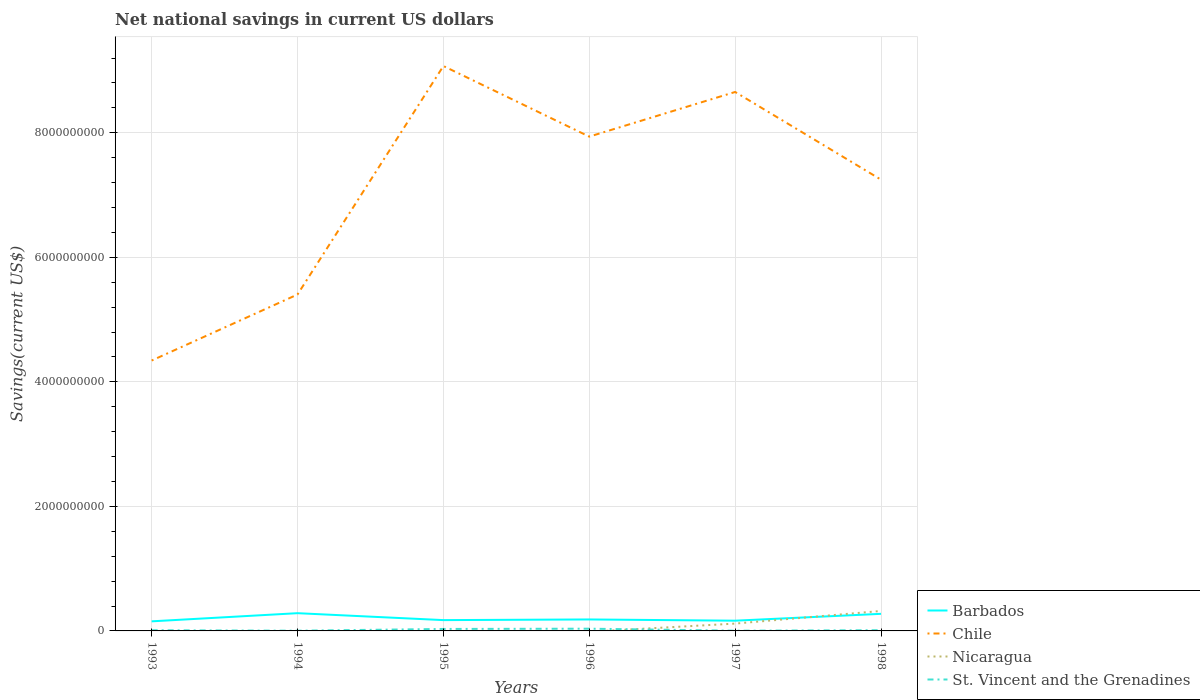How many different coloured lines are there?
Provide a succinct answer. 4. Does the line corresponding to Nicaragua intersect with the line corresponding to Barbados?
Offer a terse response. Yes. Across all years, what is the maximum net national savings in St. Vincent and the Grenadines?
Your answer should be very brief. 3.37e+06. What is the total net national savings in Barbados in the graph?
Offer a terse response. -1.10e+08. What is the difference between the highest and the second highest net national savings in Chile?
Offer a very short reply. 4.73e+09. Is the net national savings in Chile strictly greater than the net national savings in St. Vincent and the Grenadines over the years?
Offer a terse response. No. How many lines are there?
Your answer should be compact. 4. How many years are there in the graph?
Offer a terse response. 6. What is the difference between two consecutive major ticks on the Y-axis?
Keep it short and to the point. 2.00e+09. Does the graph contain grids?
Keep it short and to the point. Yes. How many legend labels are there?
Provide a succinct answer. 4. What is the title of the graph?
Offer a terse response. Net national savings in current US dollars. What is the label or title of the Y-axis?
Ensure brevity in your answer.  Savings(current US$). What is the Savings(current US$) in Barbados in 1993?
Ensure brevity in your answer.  1.54e+08. What is the Savings(current US$) in Chile in 1993?
Ensure brevity in your answer.  4.34e+09. What is the Savings(current US$) in St. Vincent and the Grenadines in 1993?
Your answer should be very brief. 1.11e+07. What is the Savings(current US$) of Barbados in 1994?
Give a very brief answer. 2.85e+08. What is the Savings(current US$) of Chile in 1994?
Your answer should be compact. 5.40e+09. What is the Savings(current US$) in St. Vincent and the Grenadines in 1994?
Provide a short and direct response. 3.37e+06. What is the Savings(current US$) in Barbados in 1995?
Your answer should be compact. 1.74e+08. What is the Savings(current US$) in Chile in 1995?
Keep it short and to the point. 9.07e+09. What is the Savings(current US$) in St. Vincent and the Grenadines in 1995?
Give a very brief answer. 3.17e+07. What is the Savings(current US$) of Barbados in 1996?
Make the answer very short. 1.84e+08. What is the Savings(current US$) of Chile in 1996?
Your answer should be compact. 7.94e+09. What is the Savings(current US$) of Nicaragua in 1996?
Make the answer very short. 0. What is the Savings(current US$) of St. Vincent and the Grenadines in 1996?
Provide a succinct answer. 3.58e+07. What is the Savings(current US$) of Barbados in 1997?
Offer a very short reply. 1.64e+08. What is the Savings(current US$) of Chile in 1997?
Your answer should be very brief. 8.65e+09. What is the Savings(current US$) of Nicaragua in 1997?
Your response must be concise. 1.18e+08. What is the Savings(current US$) of St. Vincent and the Grenadines in 1997?
Keep it short and to the point. 3.52e+06. What is the Savings(current US$) in Barbados in 1998?
Make the answer very short. 2.74e+08. What is the Savings(current US$) in Chile in 1998?
Give a very brief answer. 7.25e+09. What is the Savings(current US$) in Nicaragua in 1998?
Your response must be concise. 3.21e+08. What is the Savings(current US$) in St. Vincent and the Grenadines in 1998?
Your answer should be compact. 1.14e+07. Across all years, what is the maximum Savings(current US$) in Barbados?
Make the answer very short. 2.85e+08. Across all years, what is the maximum Savings(current US$) in Chile?
Make the answer very short. 9.07e+09. Across all years, what is the maximum Savings(current US$) in Nicaragua?
Keep it short and to the point. 3.21e+08. Across all years, what is the maximum Savings(current US$) in St. Vincent and the Grenadines?
Provide a short and direct response. 3.58e+07. Across all years, what is the minimum Savings(current US$) of Barbados?
Offer a very short reply. 1.54e+08. Across all years, what is the minimum Savings(current US$) in Chile?
Give a very brief answer. 4.34e+09. Across all years, what is the minimum Savings(current US$) in St. Vincent and the Grenadines?
Your answer should be very brief. 3.37e+06. What is the total Savings(current US$) of Barbados in the graph?
Your response must be concise. 1.24e+09. What is the total Savings(current US$) of Chile in the graph?
Give a very brief answer. 4.27e+1. What is the total Savings(current US$) in Nicaragua in the graph?
Provide a short and direct response. 4.38e+08. What is the total Savings(current US$) of St. Vincent and the Grenadines in the graph?
Your answer should be very brief. 9.69e+07. What is the difference between the Savings(current US$) of Barbados in 1993 and that in 1994?
Your response must be concise. -1.31e+08. What is the difference between the Savings(current US$) in Chile in 1993 and that in 1994?
Provide a short and direct response. -1.06e+09. What is the difference between the Savings(current US$) in St. Vincent and the Grenadines in 1993 and that in 1994?
Provide a succinct answer. 7.76e+06. What is the difference between the Savings(current US$) of Barbados in 1993 and that in 1995?
Provide a succinct answer. -1.97e+07. What is the difference between the Savings(current US$) in Chile in 1993 and that in 1995?
Your answer should be compact. -4.73e+09. What is the difference between the Savings(current US$) in St. Vincent and the Grenadines in 1993 and that in 1995?
Keep it short and to the point. -2.05e+07. What is the difference between the Savings(current US$) of Barbados in 1993 and that in 1996?
Your answer should be compact. -3.03e+07. What is the difference between the Savings(current US$) of Chile in 1993 and that in 1996?
Make the answer very short. -3.60e+09. What is the difference between the Savings(current US$) in St. Vincent and the Grenadines in 1993 and that in 1996?
Your answer should be very brief. -2.46e+07. What is the difference between the Savings(current US$) in Barbados in 1993 and that in 1997?
Provide a succinct answer. -1.05e+07. What is the difference between the Savings(current US$) of Chile in 1993 and that in 1997?
Make the answer very short. -4.31e+09. What is the difference between the Savings(current US$) in St. Vincent and the Grenadines in 1993 and that in 1997?
Make the answer very short. 7.60e+06. What is the difference between the Savings(current US$) of Barbados in 1993 and that in 1998?
Your answer should be compact. -1.21e+08. What is the difference between the Savings(current US$) in Chile in 1993 and that in 1998?
Provide a short and direct response. -2.90e+09. What is the difference between the Savings(current US$) of St. Vincent and the Grenadines in 1993 and that in 1998?
Your answer should be compact. -2.82e+05. What is the difference between the Savings(current US$) of Barbados in 1994 and that in 1995?
Keep it short and to the point. 1.11e+08. What is the difference between the Savings(current US$) in Chile in 1994 and that in 1995?
Your response must be concise. -3.67e+09. What is the difference between the Savings(current US$) in St. Vincent and the Grenadines in 1994 and that in 1995?
Offer a terse response. -2.83e+07. What is the difference between the Savings(current US$) in Barbados in 1994 and that in 1996?
Provide a short and direct response. 1.01e+08. What is the difference between the Savings(current US$) of Chile in 1994 and that in 1996?
Your answer should be compact. -2.54e+09. What is the difference between the Savings(current US$) in St. Vincent and the Grenadines in 1994 and that in 1996?
Your answer should be compact. -3.24e+07. What is the difference between the Savings(current US$) in Barbados in 1994 and that in 1997?
Offer a terse response. 1.21e+08. What is the difference between the Savings(current US$) of Chile in 1994 and that in 1997?
Make the answer very short. -3.25e+09. What is the difference between the Savings(current US$) in St. Vincent and the Grenadines in 1994 and that in 1997?
Keep it short and to the point. -1.56e+05. What is the difference between the Savings(current US$) in Barbados in 1994 and that in 1998?
Your answer should be very brief. 1.04e+07. What is the difference between the Savings(current US$) in Chile in 1994 and that in 1998?
Provide a succinct answer. -1.84e+09. What is the difference between the Savings(current US$) of St. Vincent and the Grenadines in 1994 and that in 1998?
Your answer should be compact. -8.04e+06. What is the difference between the Savings(current US$) of Barbados in 1995 and that in 1996?
Your response must be concise. -1.07e+07. What is the difference between the Savings(current US$) of Chile in 1995 and that in 1996?
Keep it short and to the point. 1.13e+09. What is the difference between the Savings(current US$) in St. Vincent and the Grenadines in 1995 and that in 1996?
Offer a terse response. -4.11e+06. What is the difference between the Savings(current US$) in Barbados in 1995 and that in 1997?
Your answer should be very brief. 9.19e+06. What is the difference between the Savings(current US$) of Chile in 1995 and that in 1997?
Ensure brevity in your answer.  4.17e+08. What is the difference between the Savings(current US$) of St. Vincent and the Grenadines in 1995 and that in 1997?
Provide a short and direct response. 2.81e+07. What is the difference between the Savings(current US$) in Barbados in 1995 and that in 1998?
Your answer should be very brief. -1.01e+08. What is the difference between the Savings(current US$) in Chile in 1995 and that in 1998?
Ensure brevity in your answer.  1.82e+09. What is the difference between the Savings(current US$) of St. Vincent and the Grenadines in 1995 and that in 1998?
Provide a short and direct response. 2.03e+07. What is the difference between the Savings(current US$) in Barbados in 1996 and that in 1997?
Provide a short and direct response. 1.99e+07. What is the difference between the Savings(current US$) in Chile in 1996 and that in 1997?
Give a very brief answer. -7.17e+08. What is the difference between the Savings(current US$) in St. Vincent and the Grenadines in 1996 and that in 1997?
Give a very brief answer. 3.22e+07. What is the difference between the Savings(current US$) in Barbados in 1996 and that in 1998?
Provide a succinct answer. -9.03e+07. What is the difference between the Savings(current US$) of Chile in 1996 and that in 1998?
Your answer should be compact. 6.91e+08. What is the difference between the Savings(current US$) in St. Vincent and the Grenadines in 1996 and that in 1998?
Ensure brevity in your answer.  2.44e+07. What is the difference between the Savings(current US$) in Barbados in 1997 and that in 1998?
Keep it short and to the point. -1.10e+08. What is the difference between the Savings(current US$) in Chile in 1997 and that in 1998?
Keep it short and to the point. 1.41e+09. What is the difference between the Savings(current US$) in Nicaragua in 1997 and that in 1998?
Your answer should be very brief. -2.03e+08. What is the difference between the Savings(current US$) of St. Vincent and the Grenadines in 1997 and that in 1998?
Give a very brief answer. -7.88e+06. What is the difference between the Savings(current US$) in Barbados in 1993 and the Savings(current US$) in Chile in 1994?
Keep it short and to the point. -5.25e+09. What is the difference between the Savings(current US$) of Barbados in 1993 and the Savings(current US$) of St. Vincent and the Grenadines in 1994?
Offer a terse response. 1.51e+08. What is the difference between the Savings(current US$) of Chile in 1993 and the Savings(current US$) of St. Vincent and the Grenadines in 1994?
Provide a short and direct response. 4.34e+09. What is the difference between the Savings(current US$) of Barbados in 1993 and the Savings(current US$) of Chile in 1995?
Provide a short and direct response. -8.92e+09. What is the difference between the Savings(current US$) of Barbados in 1993 and the Savings(current US$) of St. Vincent and the Grenadines in 1995?
Provide a short and direct response. 1.22e+08. What is the difference between the Savings(current US$) of Chile in 1993 and the Savings(current US$) of St. Vincent and the Grenadines in 1995?
Give a very brief answer. 4.31e+09. What is the difference between the Savings(current US$) in Barbados in 1993 and the Savings(current US$) in Chile in 1996?
Offer a terse response. -7.78e+09. What is the difference between the Savings(current US$) of Barbados in 1993 and the Savings(current US$) of St. Vincent and the Grenadines in 1996?
Your answer should be compact. 1.18e+08. What is the difference between the Savings(current US$) of Chile in 1993 and the Savings(current US$) of St. Vincent and the Grenadines in 1996?
Provide a short and direct response. 4.31e+09. What is the difference between the Savings(current US$) of Barbados in 1993 and the Savings(current US$) of Chile in 1997?
Give a very brief answer. -8.50e+09. What is the difference between the Savings(current US$) in Barbados in 1993 and the Savings(current US$) in Nicaragua in 1997?
Your answer should be very brief. 3.61e+07. What is the difference between the Savings(current US$) in Barbados in 1993 and the Savings(current US$) in St. Vincent and the Grenadines in 1997?
Give a very brief answer. 1.50e+08. What is the difference between the Savings(current US$) in Chile in 1993 and the Savings(current US$) in Nicaragua in 1997?
Your answer should be compact. 4.22e+09. What is the difference between the Savings(current US$) in Chile in 1993 and the Savings(current US$) in St. Vincent and the Grenadines in 1997?
Offer a very short reply. 4.34e+09. What is the difference between the Savings(current US$) in Barbados in 1993 and the Savings(current US$) in Chile in 1998?
Offer a terse response. -7.09e+09. What is the difference between the Savings(current US$) of Barbados in 1993 and the Savings(current US$) of Nicaragua in 1998?
Ensure brevity in your answer.  -1.67e+08. What is the difference between the Savings(current US$) of Barbados in 1993 and the Savings(current US$) of St. Vincent and the Grenadines in 1998?
Offer a very short reply. 1.42e+08. What is the difference between the Savings(current US$) in Chile in 1993 and the Savings(current US$) in Nicaragua in 1998?
Your response must be concise. 4.02e+09. What is the difference between the Savings(current US$) of Chile in 1993 and the Savings(current US$) of St. Vincent and the Grenadines in 1998?
Ensure brevity in your answer.  4.33e+09. What is the difference between the Savings(current US$) of Barbados in 1994 and the Savings(current US$) of Chile in 1995?
Provide a short and direct response. -8.79e+09. What is the difference between the Savings(current US$) in Barbados in 1994 and the Savings(current US$) in St. Vincent and the Grenadines in 1995?
Provide a succinct answer. 2.53e+08. What is the difference between the Savings(current US$) in Chile in 1994 and the Savings(current US$) in St. Vincent and the Grenadines in 1995?
Your answer should be very brief. 5.37e+09. What is the difference between the Savings(current US$) in Barbados in 1994 and the Savings(current US$) in Chile in 1996?
Make the answer very short. -7.65e+09. What is the difference between the Savings(current US$) in Barbados in 1994 and the Savings(current US$) in St. Vincent and the Grenadines in 1996?
Keep it short and to the point. 2.49e+08. What is the difference between the Savings(current US$) in Chile in 1994 and the Savings(current US$) in St. Vincent and the Grenadines in 1996?
Provide a succinct answer. 5.37e+09. What is the difference between the Savings(current US$) in Barbados in 1994 and the Savings(current US$) in Chile in 1997?
Your response must be concise. -8.37e+09. What is the difference between the Savings(current US$) in Barbados in 1994 and the Savings(current US$) in Nicaragua in 1997?
Your answer should be compact. 1.67e+08. What is the difference between the Savings(current US$) in Barbados in 1994 and the Savings(current US$) in St. Vincent and the Grenadines in 1997?
Your answer should be compact. 2.81e+08. What is the difference between the Savings(current US$) of Chile in 1994 and the Savings(current US$) of Nicaragua in 1997?
Offer a terse response. 5.28e+09. What is the difference between the Savings(current US$) of Chile in 1994 and the Savings(current US$) of St. Vincent and the Grenadines in 1997?
Your answer should be very brief. 5.40e+09. What is the difference between the Savings(current US$) in Barbados in 1994 and the Savings(current US$) in Chile in 1998?
Give a very brief answer. -6.96e+09. What is the difference between the Savings(current US$) of Barbados in 1994 and the Savings(current US$) of Nicaragua in 1998?
Your answer should be very brief. -3.58e+07. What is the difference between the Savings(current US$) in Barbados in 1994 and the Savings(current US$) in St. Vincent and the Grenadines in 1998?
Give a very brief answer. 2.73e+08. What is the difference between the Savings(current US$) of Chile in 1994 and the Savings(current US$) of Nicaragua in 1998?
Your answer should be compact. 5.08e+09. What is the difference between the Savings(current US$) in Chile in 1994 and the Savings(current US$) in St. Vincent and the Grenadines in 1998?
Provide a succinct answer. 5.39e+09. What is the difference between the Savings(current US$) of Barbados in 1995 and the Savings(current US$) of Chile in 1996?
Your answer should be very brief. -7.76e+09. What is the difference between the Savings(current US$) of Barbados in 1995 and the Savings(current US$) of St. Vincent and the Grenadines in 1996?
Keep it short and to the point. 1.38e+08. What is the difference between the Savings(current US$) in Chile in 1995 and the Savings(current US$) in St. Vincent and the Grenadines in 1996?
Ensure brevity in your answer.  9.04e+09. What is the difference between the Savings(current US$) in Barbados in 1995 and the Savings(current US$) in Chile in 1997?
Ensure brevity in your answer.  -8.48e+09. What is the difference between the Savings(current US$) of Barbados in 1995 and the Savings(current US$) of Nicaragua in 1997?
Your response must be concise. 5.57e+07. What is the difference between the Savings(current US$) in Barbados in 1995 and the Savings(current US$) in St. Vincent and the Grenadines in 1997?
Offer a very short reply. 1.70e+08. What is the difference between the Savings(current US$) of Chile in 1995 and the Savings(current US$) of Nicaragua in 1997?
Provide a succinct answer. 8.95e+09. What is the difference between the Savings(current US$) in Chile in 1995 and the Savings(current US$) in St. Vincent and the Grenadines in 1997?
Your answer should be compact. 9.07e+09. What is the difference between the Savings(current US$) in Barbados in 1995 and the Savings(current US$) in Chile in 1998?
Your answer should be compact. -7.07e+09. What is the difference between the Savings(current US$) in Barbados in 1995 and the Savings(current US$) in Nicaragua in 1998?
Offer a very short reply. -1.47e+08. What is the difference between the Savings(current US$) in Barbados in 1995 and the Savings(current US$) in St. Vincent and the Grenadines in 1998?
Provide a succinct answer. 1.62e+08. What is the difference between the Savings(current US$) of Chile in 1995 and the Savings(current US$) of Nicaragua in 1998?
Your answer should be compact. 8.75e+09. What is the difference between the Savings(current US$) in Chile in 1995 and the Savings(current US$) in St. Vincent and the Grenadines in 1998?
Ensure brevity in your answer.  9.06e+09. What is the difference between the Savings(current US$) in Barbados in 1996 and the Savings(current US$) in Chile in 1997?
Your response must be concise. -8.47e+09. What is the difference between the Savings(current US$) of Barbados in 1996 and the Savings(current US$) of Nicaragua in 1997?
Offer a terse response. 6.64e+07. What is the difference between the Savings(current US$) of Barbados in 1996 and the Savings(current US$) of St. Vincent and the Grenadines in 1997?
Keep it short and to the point. 1.81e+08. What is the difference between the Savings(current US$) in Chile in 1996 and the Savings(current US$) in Nicaragua in 1997?
Your answer should be very brief. 7.82e+09. What is the difference between the Savings(current US$) of Chile in 1996 and the Savings(current US$) of St. Vincent and the Grenadines in 1997?
Keep it short and to the point. 7.93e+09. What is the difference between the Savings(current US$) in Barbados in 1996 and the Savings(current US$) in Chile in 1998?
Your answer should be very brief. -7.06e+09. What is the difference between the Savings(current US$) of Barbados in 1996 and the Savings(current US$) of Nicaragua in 1998?
Your response must be concise. -1.36e+08. What is the difference between the Savings(current US$) of Barbados in 1996 and the Savings(current US$) of St. Vincent and the Grenadines in 1998?
Ensure brevity in your answer.  1.73e+08. What is the difference between the Savings(current US$) in Chile in 1996 and the Savings(current US$) in Nicaragua in 1998?
Offer a terse response. 7.62e+09. What is the difference between the Savings(current US$) in Chile in 1996 and the Savings(current US$) in St. Vincent and the Grenadines in 1998?
Provide a succinct answer. 7.93e+09. What is the difference between the Savings(current US$) in Barbados in 1997 and the Savings(current US$) in Chile in 1998?
Your answer should be very brief. -7.08e+09. What is the difference between the Savings(current US$) of Barbados in 1997 and the Savings(current US$) of Nicaragua in 1998?
Provide a short and direct response. -1.56e+08. What is the difference between the Savings(current US$) in Barbados in 1997 and the Savings(current US$) in St. Vincent and the Grenadines in 1998?
Your answer should be very brief. 1.53e+08. What is the difference between the Savings(current US$) of Chile in 1997 and the Savings(current US$) of Nicaragua in 1998?
Ensure brevity in your answer.  8.33e+09. What is the difference between the Savings(current US$) in Chile in 1997 and the Savings(current US$) in St. Vincent and the Grenadines in 1998?
Ensure brevity in your answer.  8.64e+09. What is the difference between the Savings(current US$) in Nicaragua in 1997 and the Savings(current US$) in St. Vincent and the Grenadines in 1998?
Give a very brief answer. 1.06e+08. What is the average Savings(current US$) in Barbados per year?
Your answer should be compact. 2.06e+08. What is the average Savings(current US$) of Chile per year?
Your answer should be very brief. 7.11e+09. What is the average Savings(current US$) in Nicaragua per year?
Your answer should be compact. 7.31e+07. What is the average Savings(current US$) of St. Vincent and the Grenadines per year?
Provide a succinct answer. 1.61e+07. In the year 1993, what is the difference between the Savings(current US$) in Barbados and Savings(current US$) in Chile?
Offer a terse response. -4.19e+09. In the year 1993, what is the difference between the Savings(current US$) of Barbados and Savings(current US$) of St. Vincent and the Grenadines?
Offer a terse response. 1.43e+08. In the year 1993, what is the difference between the Savings(current US$) in Chile and Savings(current US$) in St. Vincent and the Grenadines?
Keep it short and to the point. 4.33e+09. In the year 1994, what is the difference between the Savings(current US$) of Barbados and Savings(current US$) of Chile?
Give a very brief answer. -5.12e+09. In the year 1994, what is the difference between the Savings(current US$) of Barbados and Savings(current US$) of St. Vincent and the Grenadines?
Give a very brief answer. 2.82e+08. In the year 1994, what is the difference between the Savings(current US$) of Chile and Savings(current US$) of St. Vincent and the Grenadines?
Offer a terse response. 5.40e+09. In the year 1995, what is the difference between the Savings(current US$) of Barbados and Savings(current US$) of Chile?
Ensure brevity in your answer.  -8.90e+09. In the year 1995, what is the difference between the Savings(current US$) in Barbados and Savings(current US$) in St. Vincent and the Grenadines?
Make the answer very short. 1.42e+08. In the year 1995, what is the difference between the Savings(current US$) in Chile and Savings(current US$) in St. Vincent and the Grenadines?
Your answer should be very brief. 9.04e+09. In the year 1996, what is the difference between the Savings(current US$) in Barbados and Savings(current US$) in Chile?
Give a very brief answer. -7.75e+09. In the year 1996, what is the difference between the Savings(current US$) of Barbados and Savings(current US$) of St. Vincent and the Grenadines?
Provide a succinct answer. 1.48e+08. In the year 1996, what is the difference between the Savings(current US$) in Chile and Savings(current US$) in St. Vincent and the Grenadines?
Give a very brief answer. 7.90e+09. In the year 1997, what is the difference between the Savings(current US$) in Barbados and Savings(current US$) in Chile?
Offer a terse response. -8.49e+09. In the year 1997, what is the difference between the Savings(current US$) in Barbados and Savings(current US$) in Nicaragua?
Your answer should be very brief. 4.65e+07. In the year 1997, what is the difference between the Savings(current US$) of Barbados and Savings(current US$) of St. Vincent and the Grenadines?
Offer a very short reply. 1.61e+08. In the year 1997, what is the difference between the Savings(current US$) of Chile and Savings(current US$) of Nicaragua?
Offer a terse response. 8.54e+09. In the year 1997, what is the difference between the Savings(current US$) of Chile and Savings(current US$) of St. Vincent and the Grenadines?
Make the answer very short. 8.65e+09. In the year 1997, what is the difference between the Savings(current US$) of Nicaragua and Savings(current US$) of St. Vincent and the Grenadines?
Your response must be concise. 1.14e+08. In the year 1998, what is the difference between the Savings(current US$) of Barbados and Savings(current US$) of Chile?
Keep it short and to the point. -6.97e+09. In the year 1998, what is the difference between the Savings(current US$) of Barbados and Savings(current US$) of Nicaragua?
Provide a succinct answer. -4.62e+07. In the year 1998, what is the difference between the Savings(current US$) in Barbados and Savings(current US$) in St. Vincent and the Grenadines?
Ensure brevity in your answer.  2.63e+08. In the year 1998, what is the difference between the Savings(current US$) of Chile and Savings(current US$) of Nicaragua?
Keep it short and to the point. 6.93e+09. In the year 1998, what is the difference between the Savings(current US$) of Chile and Savings(current US$) of St. Vincent and the Grenadines?
Provide a succinct answer. 7.24e+09. In the year 1998, what is the difference between the Savings(current US$) in Nicaragua and Savings(current US$) in St. Vincent and the Grenadines?
Make the answer very short. 3.09e+08. What is the ratio of the Savings(current US$) in Barbados in 1993 to that in 1994?
Provide a succinct answer. 0.54. What is the ratio of the Savings(current US$) in Chile in 1993 to that in 1994?
Your answer should be compact. 0.8. What is the ratio of the Savings(current US$) in St. Vincent and the Grenadines in 1993 to that in 1994?
Offer a terse response. 3.3. What is the ratio of the Savings(current US$) in Barbados in 1993 to that in 1995?
Your answer should be compact. 0.89. What is the ratio of the Savings(current US$) of Chile in 1993 to that in 1995?
Offer a very short reply. 0.48. What is the ratio of the Savings(current US$) in St. Vincent and the Grenadines in 1993 to that in 1995?
Give a very brief answer. 0.35. What is the ratio of the Savings(current US$) in Barbados in 1993 to that in 1996?
Provide a succinct answer. 0.84. What is the ratio of the Savings(current US$) in Chile in 1993 to that in 1996?
Your answer should be very brief. 0.55. What is the ratio of the Savings(current US$) of St. Vincent and the Grenadines in 1993 to that in 1996?
Ensure brevity in your answer.  0.31. What is the ratio of the Savings(current US$) in Barbados in 1993 to that in 1997?
Offer a very short reply. 0.94. What is the ratio of the Savings(current US$) of Chile in 1993 to that in 1997?
Offer a very short reply. 0.5. What is the ratio of the Savings(current US$) in St. Vincent and the Grenadines in 1993 to that in 1997?
Your response must be concise. 3.16. What is the ratio of the Savings(current US$) of Barbados in 1993 to that in 1998?
Give a very brief answer. 0.56. What is the ratio of the Savings(current US$) of Chile in 1993 to that in 1998?
Keep it short and to the point. 0.6. What is the ratio of the Savings(current US$) of St. Vincent and the Grenadines in 1993 to that in 1998?
Keep it short and to the point. 0.98. What is the ratio of the Savings(current US$) of Barbados in 1994 to that in 1995?
Ensure brevity in your answer.  1.64. What is the ratio of the Savings(current US$) of Chile in 1994 to that in 1995?
Provide a short and direct response. 0.6. What is the ratio of the Savings(current US$) in St. Vincent and the Grenadines in 1994 to that in 1995?
Make the answer very short. 0.11. What is the ratio of the Savings(current US$) in Barbados in 1994 to that in 1996?
Your answer should be very brief. 1.55. What is the ratio of the Savings(current US$) in Chile in 1994 to that in 1996?
Give a very brief answer. 0.68. What is the ratio of the Savings(current US$) in St. Vincent and the Grenadines in 1994 to that in 1996?
Provide a short and direct response. 0.09. What is the ratio of the Savings(current US$) of Barbados in 1994 to that in 1997?
Offer a very short reply. 1.73. What is the ratio of the Savings(current US$) in Chile in 1994 to that in 1997?
Ensure brevity in your answer.  0.62. What is the ratio of the Savings(current US$) in St. Vincent and the Grenadines in 1994 to that in 1997?
Your answer should be very brief. 0.96. What is the ratio of the Savings(current US$) in Barbados in 1994 to that in 1998?
Provide a succinct answer. 1.04. What is the ratio of the Savings(current US$) in Chile in 1994 to that in 1998?
Your answer should be very brief. 0.75. What is the ratio of the Savings(current US$) of St. Vincent and the Grenadines in 1994 to that in 1998?
Keep it short and to the point. 0.3. What is the ratio of the Savings(current US$) in Barbados in 1995 to that in 1996?
Make the answer very short. 0.94. What is the ratio of the Savings(current US$) of Chile in 1995 to that in 1996?
Give a very brief answer. 1.14. What is the ratio of the Savings(current US$) in St. Vincent and the Grenadines in 1995 to that in 1996?
Make the answer very short. 0.89. What is the ratio of the Savings(current US$) of Barbados in 1995 to that in 1997?
Give a very brief answer. 1.06. What is the ratio of the Savings(current US$) of Chile in 1995 to that in 1997?
Offer a very short reply. 1.05. What is the ratio of the Savings(current US$) in St. Vincent and the Grenadines in 1995 to that in 1997?
Your answer should be very brief. 8.98. What is the ratio of the Savings(current US$) in Barbados in 1995 to that in 1998?
Your answer should be compact. 0.63. What is the ratio of the Savings(current US$) in Chile in 1995 to that in 1998?
Give a very brief answer. 1.25. What is the ratio of the Savings(current US$) in St. Vincent and the Grenadines in 1995 to that in 1998?
Offer a very short reply. 2.78. What is the ratio of the Savings(current US$) of Barbados in 1996 to that in 1997?
Provide a succinct answer. 1.12. What is the ratio of the Savings(current US$) in Chile in 1996 to that in 1997?
Make the answer very short. 0.92. What is the ratio of the Savings(current US$) of St. Vincent and the Grenadines in 1996 to that in 1997?
Give a very brief answer. 10.15. What is the ratio of the Savings(current US$) of Barbados in 1996 to that in 1998?
Keep it short and to the point. 0.67. What is the ratio of the Savings(current US$) of Chile in 1996 to that in 1998?
Keep it short and to the point. 1.1. What is the ratio of the Savings(current US$) of St. Vincent and the Grenadines in 1996 to that in 1998?
Provide a succinct answer. 3.14. What is the ratio of the Savings(current US$) of Barbados in 1997 to that in 1998?
Keep it short and to the point. 0.6. What is the ratio of the Savings(current US$) of Chile in 1997 to that in 1998?
Give a very brief answer. 1.19. What is the ratio of the Savings(current US$) of Nicaragua in 1997 to that in 1998?
Offer a very short reply. 0.37. What is the ratio of the Savings(current US$) in St. Vincent and the Grenadines in 1997 to that in 1998?
Offer a terse response. 0.31. What is the difference between the highest and the second highest Savings(current US$) of Barbados?
Provide a short and direct response. 1.04e+07. What is the difference between the highest and the second highest Savings(current US$) of Chile?
Offer a terse response. 4.17e+08. What is the difference between the highest and the second highest Savings(current US$) of St. Vincent and the Grenadines?
Your answer should be compact. 4.11e+06. What is the difference between the highest and the lowest Savings(current US$) in Barbados?
Ensure brevity in your answer.  1.31e+08. What is the difference between the highest and the lowest Savings(current US$) of Chile?
Give a very brief answer. 4.73e+09. What is the difference between the highest and the lowest Savings(current US$) of Nicaragua?
Your answer should be very brief. 3.21e+08. What is the difference between the highest and the lowest Savings(current US$) in St. Vincent and the Grenadines?
Provide a succinct answer. 3.24e+07. 